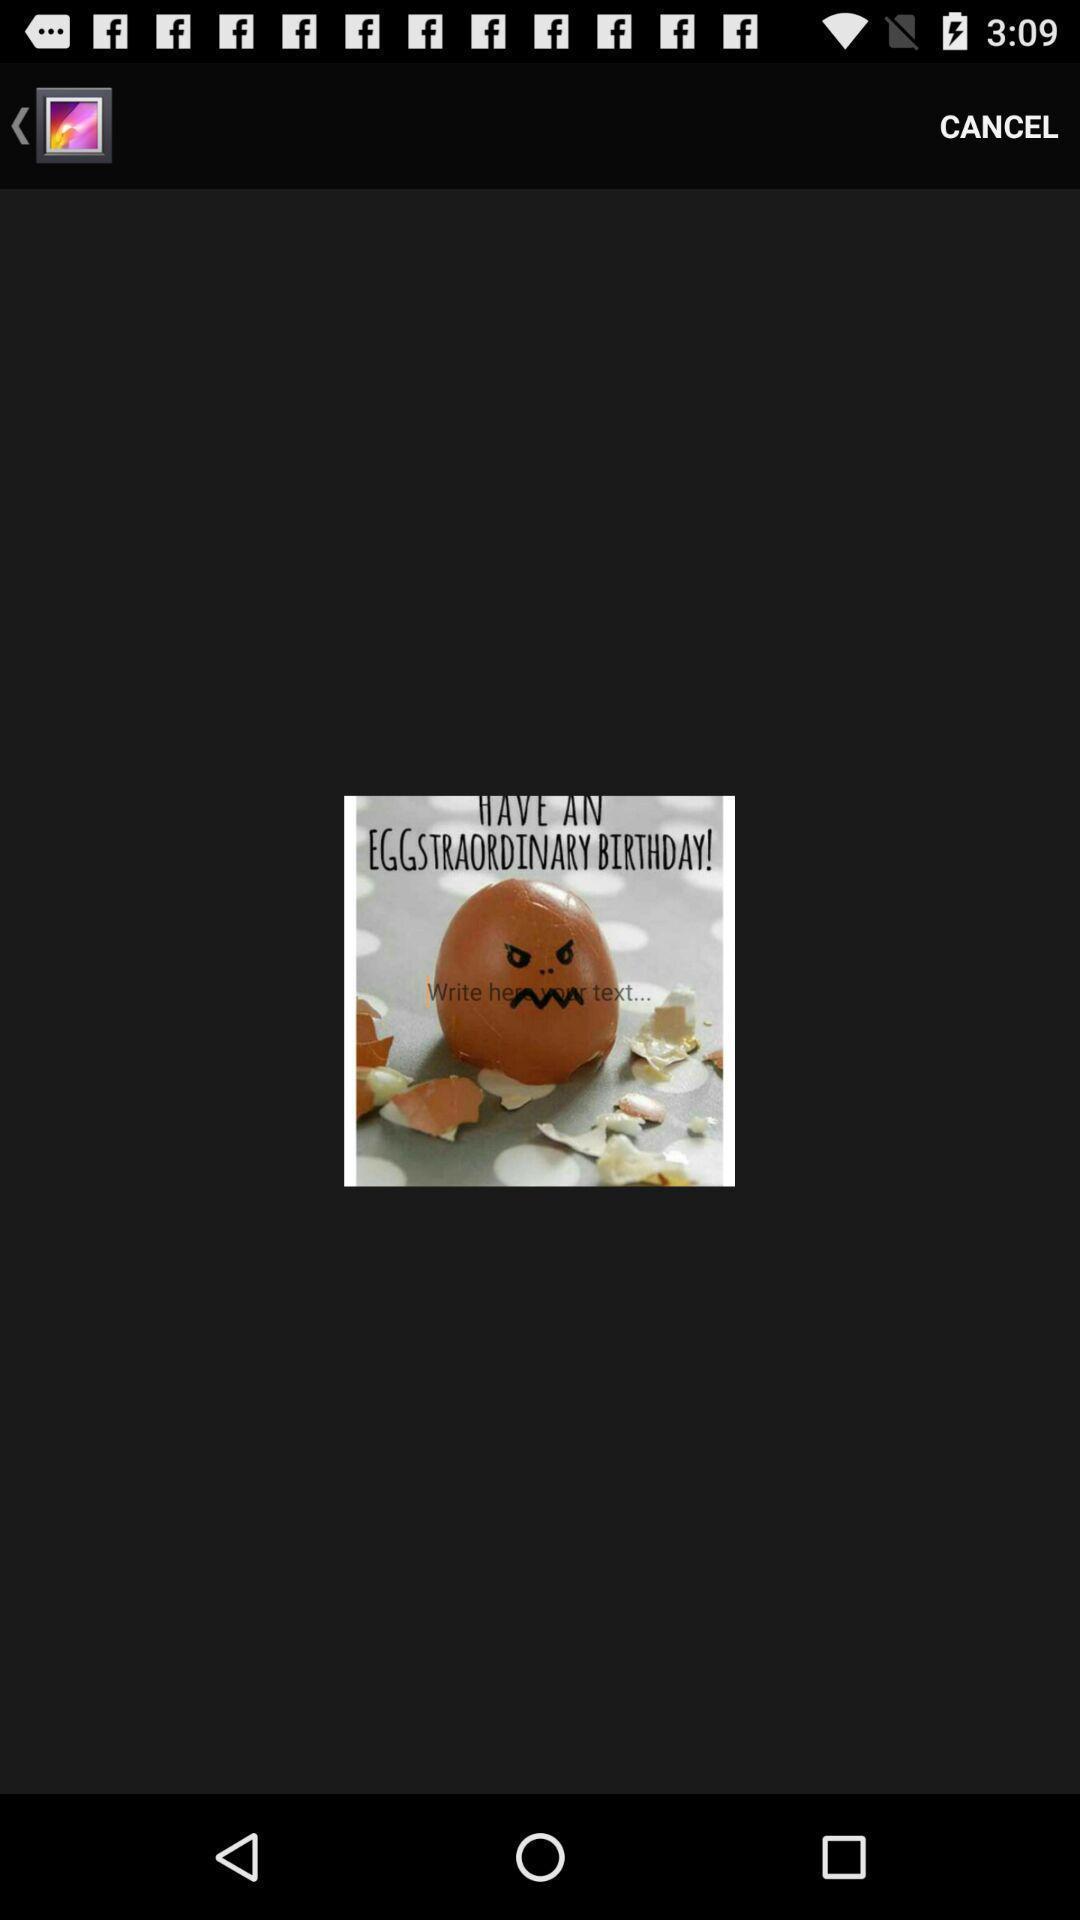Provide a textual representation of this image. Screen page displaying an image with cancel icon. 